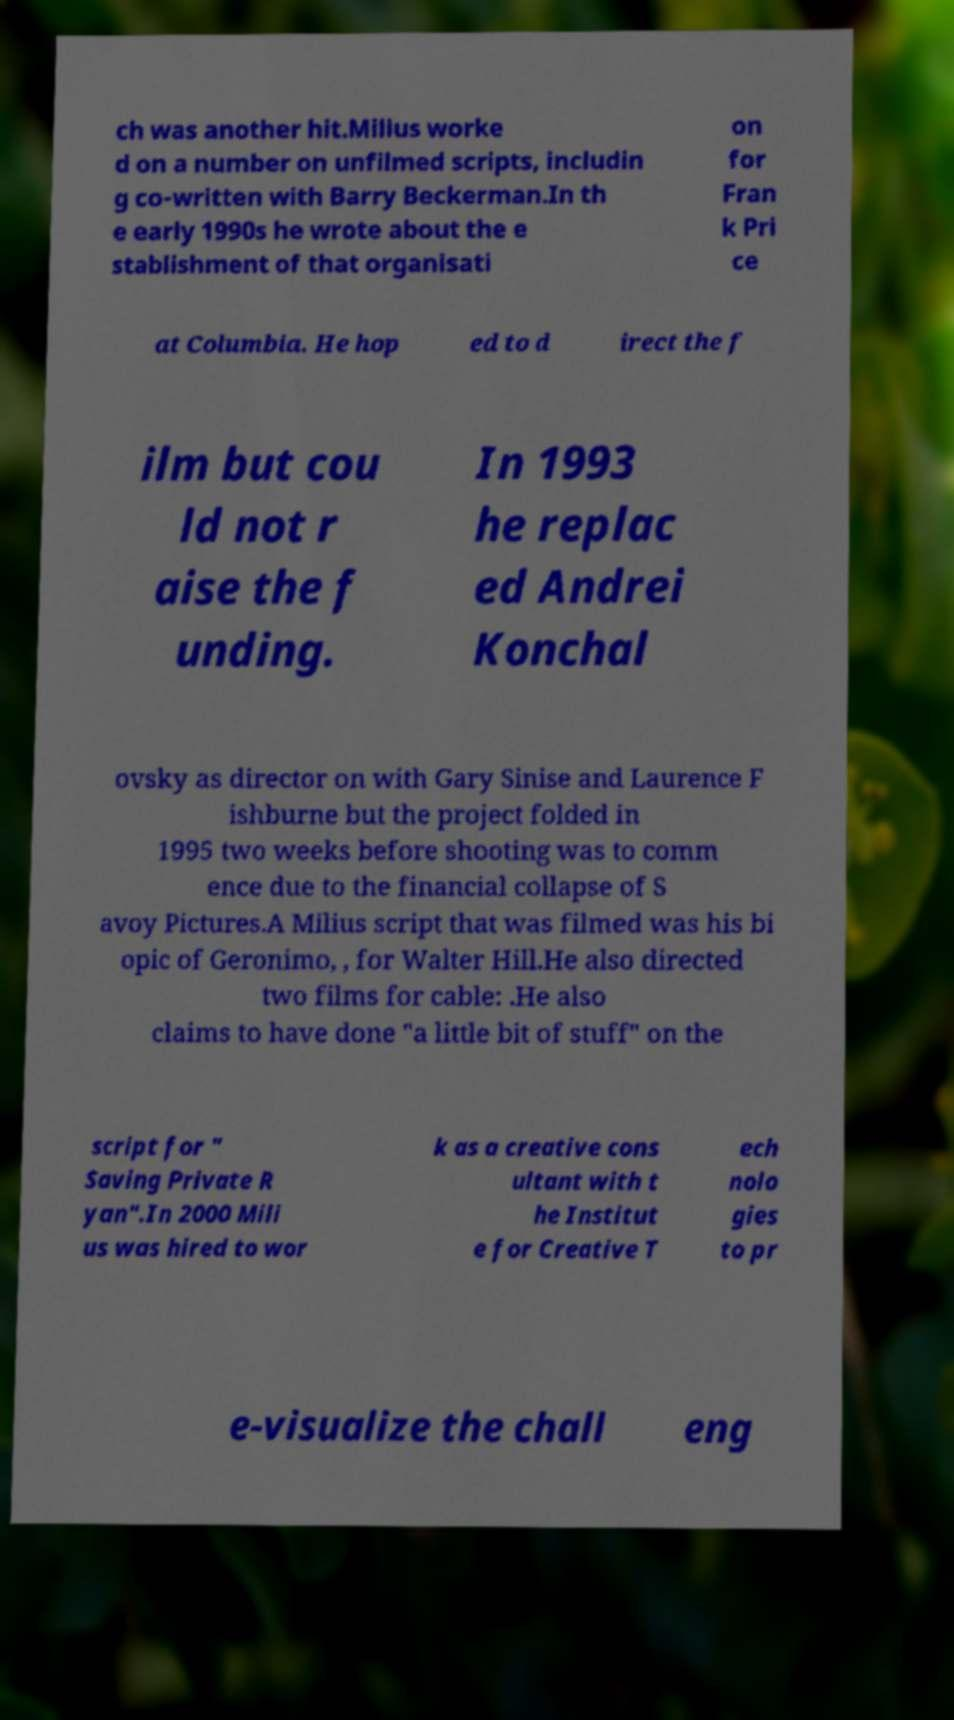Please read and relay the text visible in this image. What does it say? ch was another hit.Milius worke d on a number on unfilmed scripts, includin g co-written with Barry Beckerman.In th e early 1990s he wrote about the e stablishment of that organisati on for Fran k Pri ce at Columbia. He hop ed to d irect the f ilm but cou ld not r aise the f unding. In 1993 he replac ed Andrei Konchal ovsky as director on with Gary Sinise and Laurence F ishburne but the project folded in 1995 two weeks before shooting was to comm ence due to the financial collapse of S avoy Pictures.A Milius script that was filmed was his bi opic of Geronimo, , for Walter Hill.He also directed two films for cable: .He also claims to have done "a little bit of stuff" on the script for " Saving Private R yan".In 2000 Mili us was hired to wor k as a creative cons ultant with t he Institut e for Creative T ech nolo gies to pr e-visualize the chall eng 